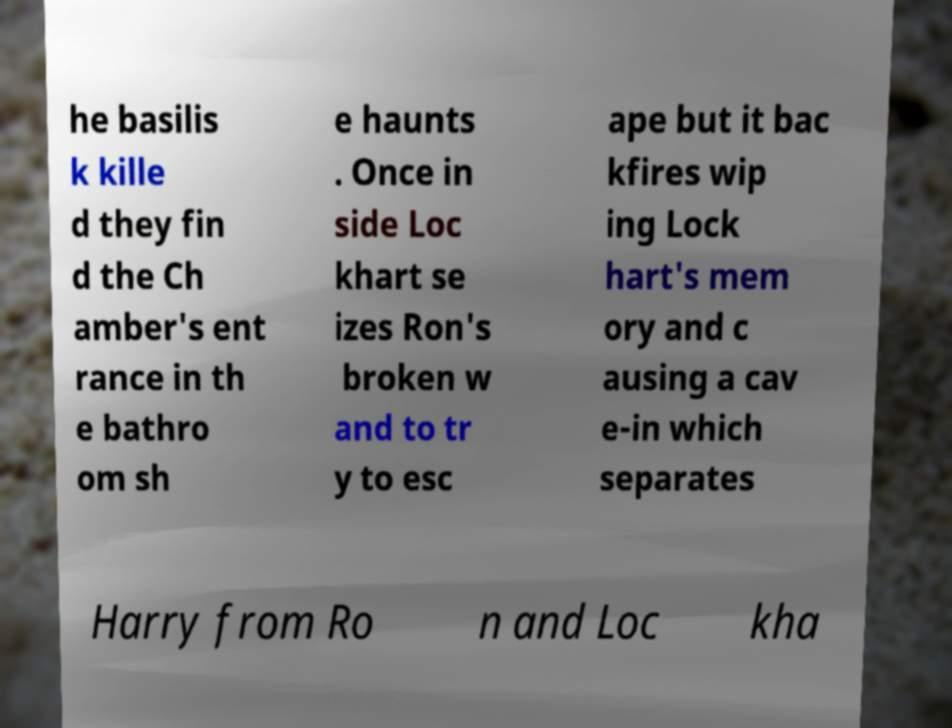For documentation purposes, I need the text within this image transcribed. Could you provide that? he basilis k kille d they fin d the Ch amber's ent rance in th e bathro om sh e haunts . Once in side Loc khart se izes Ron's broken w and to tr y to esc ape but it bac kfires wip ing Lock hart's mem ory and c ausing a cav e-in which separates Harry from Ro n and Loc kha 